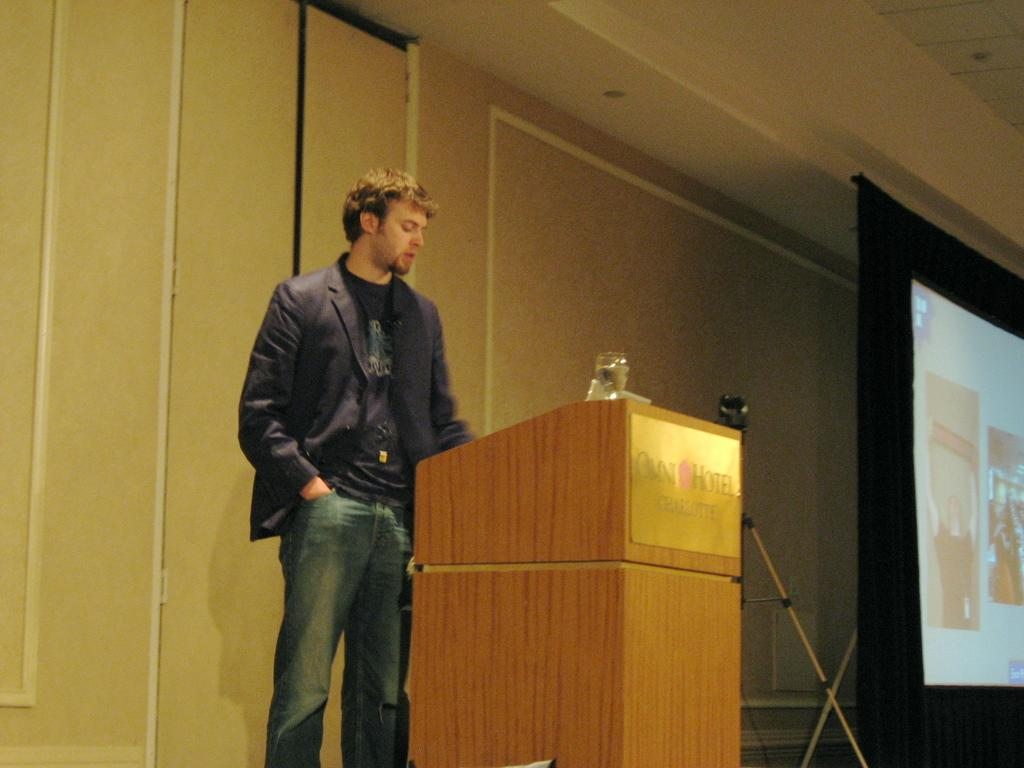Who is present in the image? There is a man in the image. What is the man wearing? The man is wearing a jacket and jeans. Where is the man standing in the image? The man is standing in front of a dias. What can be seen on the right side of the image? There is a screen on the right side of the image. What is the screen positioned in front of? The screen is in front of a wall. How much salt is on the man's jacket in the image? There is no salt visible on the man's jacket in the image. Is there a knot tied in the man's jeans in the image? There is no mention of a knot in the man's jeans in the image. 